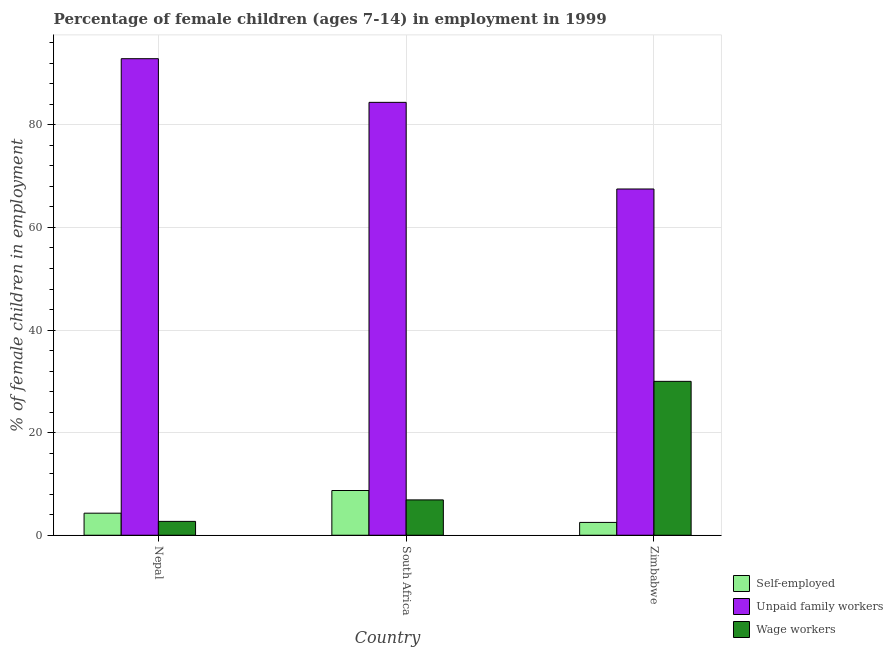How many different coloured bars are there?
Offer a terse response. 3. How many groups of bars are there?
Make the answer very short. 3. Are the number of bars per tick equal to the number of legend labels?
Give a very brief answer. Yes. Are the number of bars on each tick of the X-axis equal?
Provide a short and direct response. Yes. What is the label of the 1st group of bars from the left?
Offer a terse response. Nepal. In how many cases, is the number of bars for a given country not equal to the number of legend labels?
Provide a succinct answer. 0. What is the percentage of self employed children in Zimbabwe?
Keep it short and to the point. 2.5. Across all countries, what is the maximum percentage of children employed as unpaid family workers?
Make the answer very short. 92.9. Across all countries, what is the minimum percentage of children employed as wage workers?
Make the answer very short. 2.7. In which country was the percentage of children employed as unpaid family workers maximum?
Give a very brief answer. Nepal. In which country was the percentage of children employed as wage workers minimum?
Make the answer very short. Nepal. What is the total percentage of children employed as unpaid family workers in the graph?
Keep it short and to the point. 244.79. What is the difference between the percentage of children employed as wage workers in Nepal and that in South Africa?
Offer a very short reply. -4.19. What is the difference between the percentage of self employed children in Zimbabwe and the percentage of children employed as unpaid family workers in Nepal?
Provide a succinct answer. -90.4. What is the average percentage of children employed as wage workers per country?
Provide a succinct answer. 13.2. What is the difference between the percentage of children employed as unpaid family workers and percentage of children employed as wage workers in Zimbabwe?
Provide a succinct answer. 37.5. What is the ratio of the percentage of self employed children in Nepal to that in Zimbabwe?
Ensure brevity in your answer.  1.72. Is the percentage of children employed as wage workers in Nepal less than that in Zimbabwe?
Make the answer very short. Yes. Is the difference between the percentage of children employed as unpaid family workers in South Africa and Zimbabwe greater than the difference between the percentage of self employed children in South Africa and Zimbabwe?
Make the answer very short. Yes. What is the difference between the highest and the second highest percentage of children employed as unpaid family workers?
Keep it short and to the point. 8.51. What is the difference between the highest and the lowest percentage of self employed children?
Provide a short and direct response. 6.22. Is the sum of the percentage of children employed as unpaid family workers in South Africa and Zimbabwe greater than the maximum percentage of self employed children across all countries?
Make the answer very short. Yes. What does the 1st bar from the left in Nepal represents?
Ensure brevity in your answer.  Self-employed. What does the 1st bar from the right in Zimbabwe represents?
Your answer should be compact. Wage workers. Is it the case that in every country, the sum of the percentage of self employed children and percentage of children employed as unpaid family workers is greater than the percentage of children employed as wage workers?
Your answer should be very brief. Yes. Are all the bars in the graph horizontal?
Make the answer very short. No. What is the difference between two consecutive major ticks on the Y-axis?
Keep it short and to the point. 20. Does the graph contain grids?
Your answer should be very brief. Yes. How many legend labels are there?
Your response must be concise. 3. How are the legend labels stacked?
Ensure brevity in your answer.  Vertical. What is the title of the graph?
Offer a very short reply. Percentage of female children (ages 7-14) in employment in 1999. What is the label or title of the X-axis?
Keep it short and to the point. Country. What is the label or title of the Y-axis?
Offer a terse response. % of female children in employment. What is the % of female children in employment in Unpaid family workers in Nepal?
Your answer should be compact. 92.9. What is the % of female children in employment in Self-employed in South Africa?
Offer a terse response. 8.72. What is the % of female children in employment of Unpaid family workers in South Africa?
Keep it short and to the point. 84.39. What is the % of female children in employment in Wage workers in South Africa?
Offer a terse response. 6.89. What is the % of female children in employment in Unpaid family workers in Zimbabwe?
Your answer should be compact. 67.5. What is the % of female children in employment in Wage workers in Zimbabwe?
Provide a succinct answer. 30. Across all countries, what is the maximum % of female children in employment of Self-employed?
Ensure brevity in your answer.  8.72. Across all countries, what is the maximum % of female children in employment in Unpaid family workers?
Make the answer very short. 92.9. Across all countries, what is the minimum % of female children in employment in Self-employed?
Provide a short and direct response. 2.5. Across all countries, what is the minimum % of female children in employment in Unpaid family workers?
Provide a short and direct response. 67.5. Across all countries, what is the minimum % of female children in employment in Wage workers?
Provide a short and direct response. 2.7. What is the total % of female children in employment in Self-employed in the graph?
Your answer should be compact. 15.52. What is the total % of female children in employment in Unpaid family workers in the graph?
Ensure brevity in your answer.  244.79. What is the total % of female children in employment of Wage workers in the graph?
Your answer should be compact. 39.59. What is the difference between the % of female children in employment in Self-employed in Nepal and that in South Africa?
Your response must be concise. -4.42. What is the difference between the % of female children in employment in Unpaid family workers in Nepal and that in South Africa?
Your answer should be compact. 8.51. What is the difference between the % of female children in employment of Wage workers in Nepal and that in South Africa?
Offer a terse response. -4.19. What is the difference between the % of female children in employment of Unpaid family workers in Nepal and that in Zimbabwe?
Offer a very short reply. 25.4. What is the difference between the % of female children in employment of Wage workers in Nepal and that in Zimbabwe?
Your response must be concise. -27.3. What is the difference between the % of female children in employment in Self-employed in South Africa and that in Zimbabwe?
Your answer should be compact. 6.22. What is the difference between the % of female children in employment in Unpaid family workers in South Africa and that in Zimbabwe?
Keep it short and to the point. 16.89. What is the difference between the % of female children in employment of Wage workers in South Africa and that in Zimbabwe?
Give a very brief answer. -23.11. What is the difference between the % of female children in employment of Self-employed in Nepal and the % of female children in employment of Unpaid family workers in South Africa?
Ensure brevity in your answer.  -80.09. What is the difference between the % of female children in employment of Self-employed in Nepal and the % of female children in employment of Wage workers in South Africa?
Keep it short and to the point. -2.59. What is the difference between the % of female children in employment in Unpaid family workers in Nepal and the % of female children in employment in Wage workers in South Africa?
Give a very brief answer. 86.01. What is the difference between the % of female children in employment in Self-employed in Nepal and the % of female children in employment in Unpaid family workers in Zimbabwe?
Offer a terse response. -63.2. What is the difference between the % of female children in employment of Self-employed in Nepal and the % of female children in employment of Wage workers in Zimbabwe?
Provide a short and direct response. -25.7. What is the difference between the % of female children in employment in Unpaid family workers in Nepal and the % of female children in employment in Wage workers in Zimbabwe?
Ensure brevity in your answer.  62.9. What is the difference between the % of female children in employment of Self-employed in South Africa and the % of female children in employment of Unpaid family workers in Zimbabwe?
Your answer should be very brief. -58.78. What is the difference between the % of female children in employment in Self-employed in South Africa and the % of female children in employment in Wage workers in Zimbabwe?
Ensure brevity in your answer.  -21.28. What is the difference between the % of female children in employment in Unpaid family workers in South Africa and the % of female children in employment in Wage workers in Zimbabwe?
Provide a short and direct response. 54.39. What is the average % of female children in employment of Self-employed per country?
Provide a succinct answer. 5.17. What is the average % of female children in employment of Unpaid family workers per country?
Make the answer very short. 81.6. What is the average % of female children in employment in Wage workers per country?
Ensure brevity in your answer.  13.2. What is the difference between the % of female children in employment in Self-employed and % of female children in employment in Unpaid family workers in Nepal?
Offer a very short reply. -88.6. What is the difference between the % of female children in employment in Unpaid family workers and % of female children in employment in Wage workers in Nepal?
Offer a very short reply. 90.2. What is the difference between the % of female children in employment in Self-employed and % of female children in employment in Unpaid family workers in South Africa?
Ensure brevity in your answer.  -75.67. What is the difference between the % of female children in employment of Self-employed and % of female children in employment of Wage workers in South Africa?
Provide a short and direct response. 1.83. What is the difference between the % of female children in employment in Unpaid family workers and % of female children in employment in Wage workers in South Africa?
Offer a terse response. 77.5. What is the difference between the % of female children in employment in Self-employed and % of female children in employment in Unpaid family workers in Zimbabwe?
Ensure brevity in your answer.  -65. What is the difference between the % of female children in employment in Self-employed and % of female children in employment in Wage workers in Zimbabwe?
Offer a very short reply. -27.5. What is the difference between the % of female children in employment in Unpaid family workers and % of female children in employment in Wage workers in Zimbabwe?
Keep it short and to the point. 37.5. What is the ratio of the % of female children in employment of Self-employed in Nepal to that in South Africa?
Keep it short and to the point. 0.49. What is the ratio of the % of female children in employment of Unpaid family workers in Nepal to that in South Africa?
Make the answer very short. 1.1. What is the ratio of the % of female children in employment in Wage workers in Nepal to that in South Africa?
Ensure brevity in your answer.  0.39. What is the ratio of the % of female children in employment of Self-employed in Nepal to that in Zimbabwe?
Make the answer very short. 1.72. What is the ratio of the % of female children in employment of Unpaid family workers in Nepal to that in Zimbabwe?
Give a very brief answer. 1.38. What is the ratio of the % of female children in employment of Wage workers in Nepal to that in Zimbabwe?
Your response must be concise. 0.09. What is the ratio of the % of female children in employment in Self-employed in South Africa to that in Zimbabwe?
Your response must be concise. 3.49. What is the ratio of the % of female children in employment of Unpaid family workers in South Africa to that in Zimbabwe?
Ensure brevity in your answer.  1.25. What is the ratio of the % of female children in employment of Wage workers in South Africa to that in Zimbabwe?
Give a very brief answer. 0.23. What is the difference between the highest and the second highest % of female children in employment in Self-employed?
Give a very brief answer. 4.42. What is the difference between the highest and the second highest % of female children in employment in Unpaid family workers?
Your answer should be very brief. 8.51. What is the difference between the highest and the second highest % of female children in employment of Wage workers?
Provide a succinct answer. 23.11. What is the difference between the highest and the lowest % of female children in employment of Self-employed?
Your answer should be compact. 6.22. What is the difference between the highest and the lowest % of female children in employment of Unpaid family workers?
Your response must be concise. 25.4. What is the difference between the highest and the lowest % of female children in employment of Wage workers?
Your answer should be compact. 27.3. 